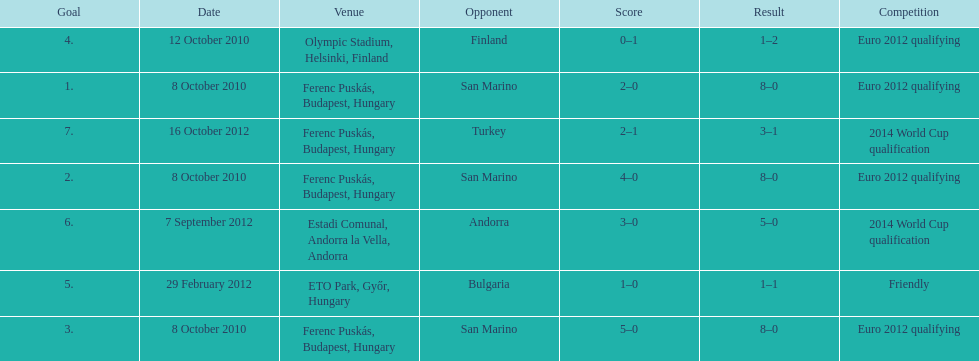How many goals were scored at the euro 2012 qualifying competition? 12. 